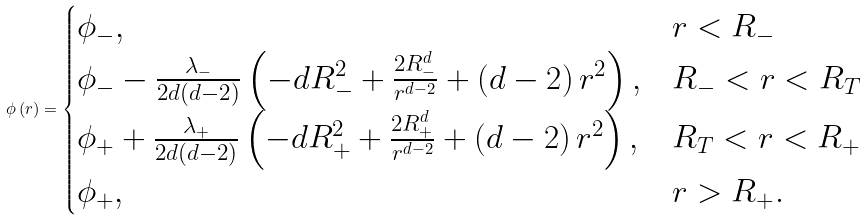<formula> <loc_0><loc_0><loc_500><loc_500>\phi \left ( r \right ) = \begin{cases} \phi _ { - } , & r < R _ { - } \\ \phi _ { - } - \frac { \lambda _ { - } } { { 2 d \left ( { d - 2 } \right ) } } \left ( { - d R _ { - } ^ { 2 } + \frac { 2 R _ { - } ^ { d } } { { r ^ { d - 2 } } } + \left ( { d - 2 } \right ) r ^ { 2 } } \right ) , & R _ { - } < r < R _ { T } \\ \phi _ { + } + \frac { \lambda _ { + } } { { 2 d \left ( { d - 2 } \right ) } } \left ( { - d R _ { + } ^ { 2 } + \frac { 2 R _ { + } ^ { d } } { { r ^ { d - 2 } } } + \left ( { d - 2 } \right ) r ^ { 2 } } \right ) , & R _ { T } < r < R _ { + } \\ \phi _ { + } , & r > R _ { + } . \\ \end{cases}</formula> 